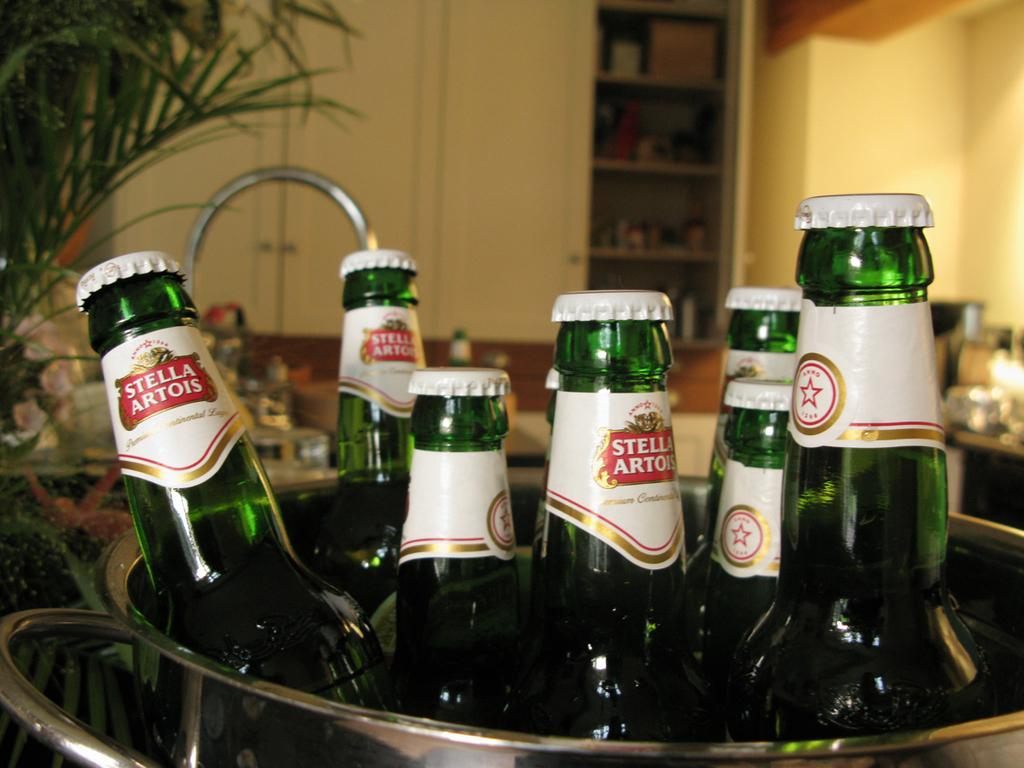<image>
Share a concise interpretation of the image provided. Bottles of Stella Artois beer sitting in an aluminum bucket 